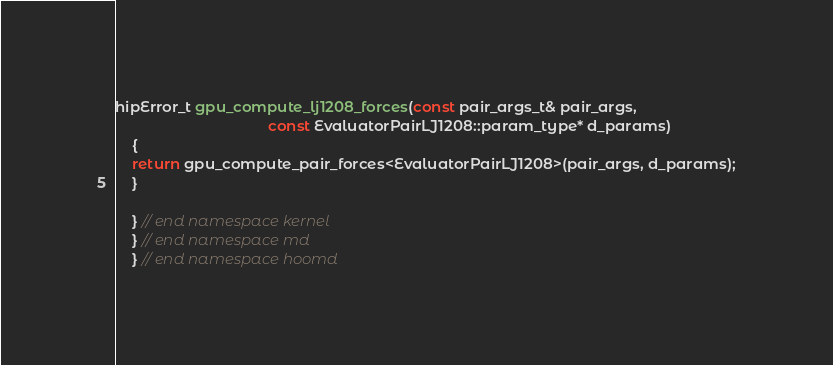<code> <loc_0><loc_0><loc_500><loc_500><_Cuda_>hipError_t gpu_compute_lj1208_forces(const pair_args_t& pair_args,
                                     const EvaluatorPairLJ1208::param_type* d_params)
    {
    return gpu_compute_pair_forces<EvaluatorPairLJ1208>(pair_args, d_params);
    }

    } // end namespace kernel
    } // end namespace md
    } // end namespace hoomd
</code> 